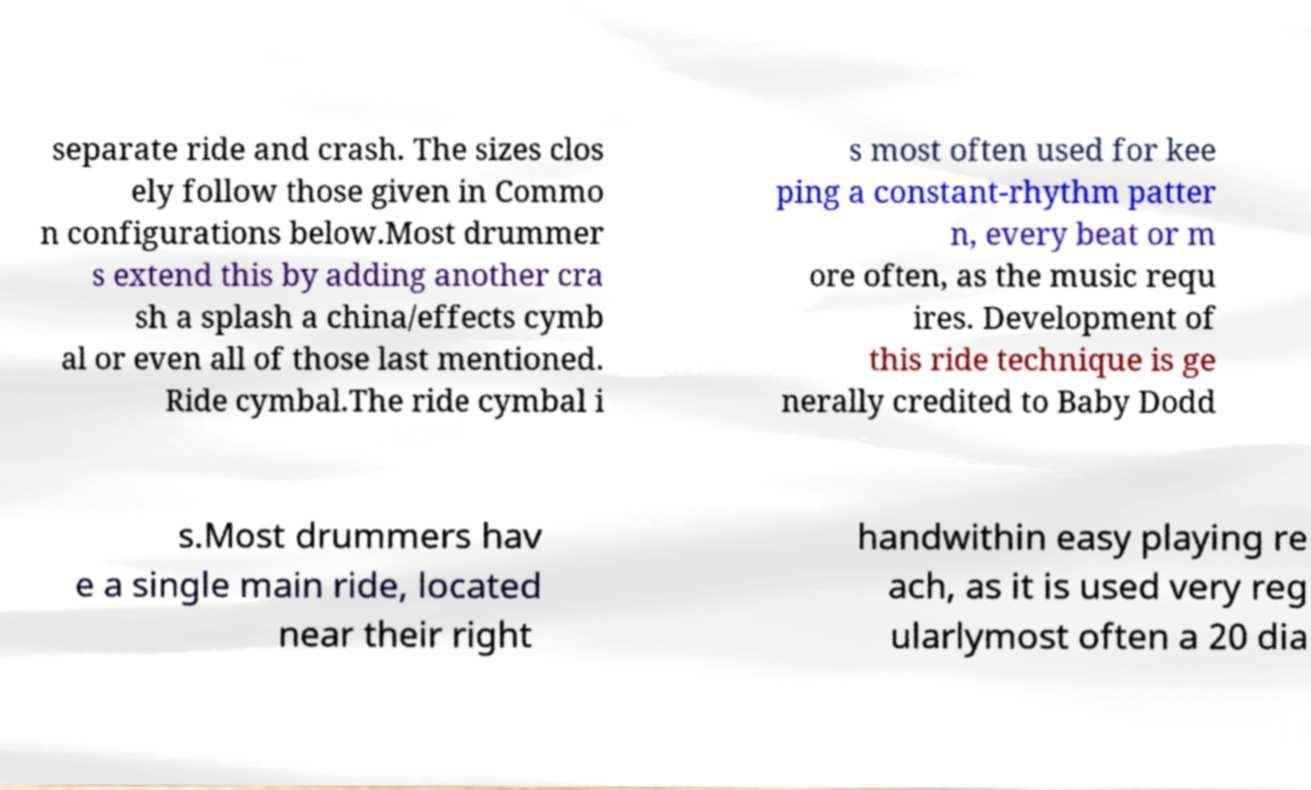Please read and relay the text visible in this image. What does it say? separate ride and crash. The sizes clos ely follow those given in Commo n configurations below.Most drummer s extend this by adding another cra sh a splash a china/effects cymb al or even all of those last mentioned. Ride cymbal.The ride cymbal i s most often used for kee ping a constant-rhythm patter n, every beat or m ore often, as the music requ ires. Development of this ride technique is ge nerally credited to Baby Dodd s.Most drummers hav e a single main ride, located near their right handwithin easy playing re ach, as it is used very reg ularlymost often a 20 dia 